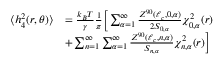<formula> <loc_0><loc_0><loc_500><loc_500>\begin{array} { r l } { \langle h _ { 4 } ^ { 2 } ( r , \theta ) \rangle } & { = \frac { k _ { B } T } { \gamma } \frac { 1 } { \pi } \left [ \sum _ { \alpha = 1 } ^ { \infty } \frac { Z ^ { 9 0 } ( \ell _ { c } , 0 , \alpha ) } { 2 S _ { 0 , \alpha } } \chi _ { 0 , \alpha } ^ { 2 } ( r ) } \\ & { + \sum _ { n = 1 } ^ { \infty } \sum _ { \alpha = 1 } ^ { \infty } \frac { Z ^ { 9 0 } ( \ell _ { c } , n , \alpha ) } { S _ { n , \alpha } } \chi _ { n , \alpha } ^ { 2 } ( r ) \right ] } \end{array}</formula> 